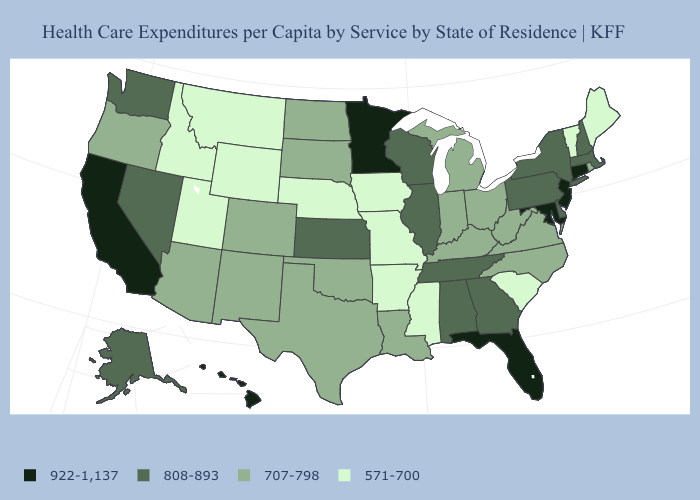Name the states that have a value in the range 707-798?
Concise answer only. Arizona, Colorado, Indiana, Kentucky, Louisiana, Michigan, New Mexico, North Carolina, North Dakota, Ohio, Oklahoma, Oregon, Rhode Island, South Dakota, Texas, Virginia, West Virginia. Does Rhode Island have the lowest value in the Northeast?
Answer briefly. No. Does the first symbol in the legend represent the smallest category?
Quick response, please. No. What is the value of Minnesota?
Be succinct. 922-1,137. What is the lowest value in the USA?
Concise answer only. 571-700. Name the states that have a value in the range 571-700?
Keep it brief. Arkansas, Idaho, Iowa, Maine, Mississippi, Missouri, Montana, Nebraska, South Carolina, Utah, Vermont, Wyoming. What is the value of Arkansas?
Be succinct. 571-700. Among the states that border Nevada , which have the highest value?
Answer briefly. California. Which states have the highest value in the USA?
Give a very brief answer. California, Connecticut, Florida, Hawaii, Maryland, Minnesota, New Jersey. What is the value of Indiana?
Quick response, please. 707-798. Name the states that have a value in the range 808-893?
Write a very short answer. Alabama, Alaska, Delaware, Georgia, Illinois, Kansas, Massachusetts, Nevada, New Hampshire, New York, Pennsylvania, Tennessee, Washington, Wisconsin. What is the value of New York?
Keep it brief. 808-893. Is the legend a continuous bar?
Keep it brief. No. Does the map have missing data?
Short answer required. No. Name the states that have a value in the range 571-700?
Write a very short answer. Arkansas, Idaho, Iowa, Maine, Mississippi, Missouri, Montana, Nebraska, South Carolina, Utah, Vermont, Wyoming. 